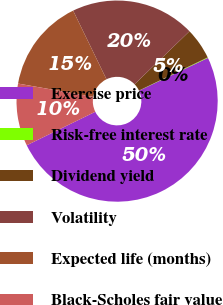Convert chart to OTSL. <chart><loc_0><loc_0><loc_500><loc_500><pie_chart><fcel>Exercise price<fcel>Risk-free interest rate<fcel>Dividend yield<fcel>Volatility<fcel>Expected life (months)<fcel>Black-Scholes fair value<nl><fcel>49.83%<fcel>0.09%<fcel>5.06%<fcel>19.98%<fcel>15.01%<fcel>10.03%<nl></chart> 